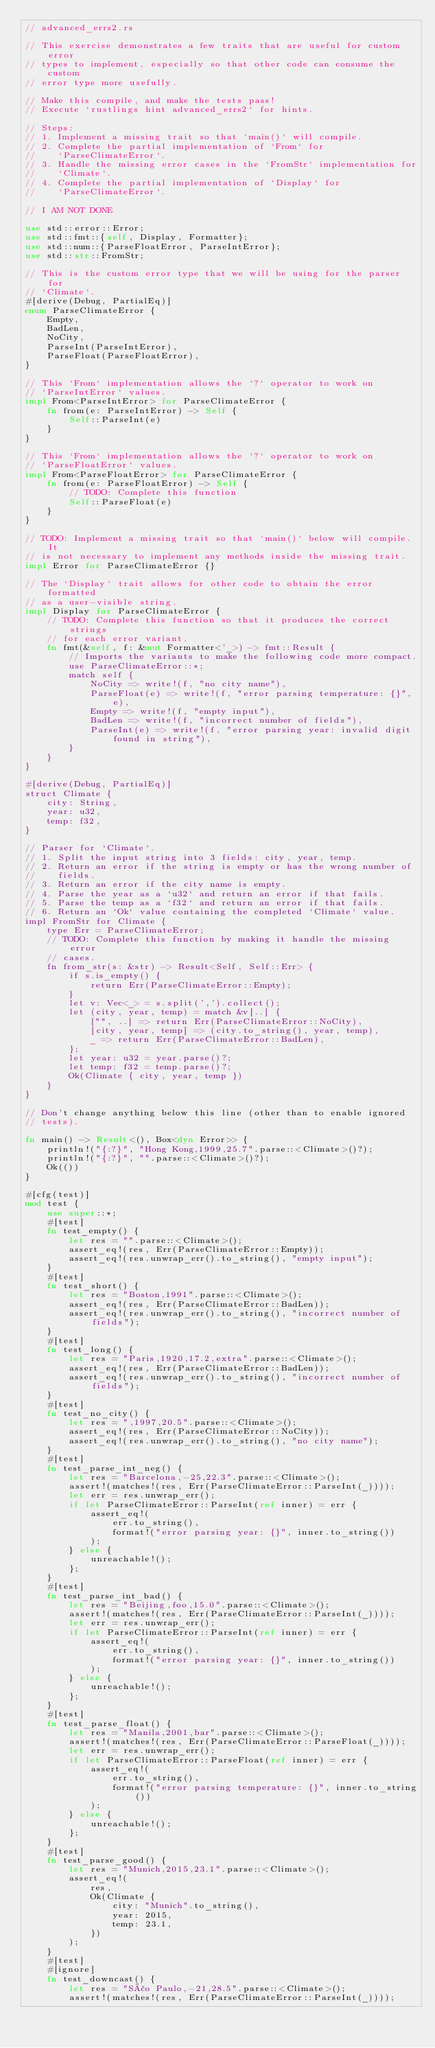<code> <loc_0><loc_0><loc_500><loc_500><_Rust_>// advanced_errs2.rs

// This exercise demonstrates a few traits that are useful for custom error
// types to implement, especially so that other code can consume the custom
// error type more usefully.

// Make this compile, and make the tests pass!
// Execute `rustlings hint advanced_errs2` for hints.

// Steps:
// 1. Implement a missing trait so that `main()` will compile.
// 2. Complete the partial implementation of `From` for
//    `ParseClimateError`.
// 3. Handle the missing error cases in the `FromStr` implementation for
//    `Climate`.
// 4. Complete the partial implementation of `Display` for
//    `ParseClimateError`.

// I AM NOT DONE

use std::error::Error;
use std::fmt::{self, Display, Formatter};
use std::num::{ParseFloatError, ParseIntError};
use std::str::FromStr;

// This is the custom error type that we will be using for the parser for
// `Climate`.
#[derive(Debug, PartialEq)]
enum ParseClimateError {
    Empty,
    BadLen,
    NoCity,
    ParseInt(ParseIntError),
    ParseFloat(ParseFloatError),
}

// This `From` implementation allows the `?` operator to work on
// `ParseIntError` values.
impl From<ParseIntError> for ParseClimateError {
    fn from(e: ParseIntError) -> Self {
        Self::ParseInt(e)
    }
}

// This `From` implementation allows the `?` operator to work on
// `ParseFloatError` values.
impl From<ParseFloatError> for ParseClimateError {
    fn from(e: ParseFloatError) -> Self {
        // TODO: Complete this function
        Self::ParseFloat(e)
    }
}

// TODO: Implement a missing trait so that `main()` below will compile. It
// is not necessary to implement any methods inside the missing trait.
impl Error for ParseClimateError {}

// The `Display` trait allows for other code to obtain the error formatted
// as a user-visible string.
impl Display for ParseClimateError {
    // TODO: Complete this function so that it produces the correct strings
    // for each error variant.
    fn fmt(&self, f: &mut Formatter<'_>) -> fmt::Result {
        // Imports the variants to make the following code more compact.
        use ParseClimateError::*;
        match self {
            NoCity => write!(f, "no city name"),
            ParseFloat(e) => write!(f, "error parsing temperature: {}", e),
            Empty => write!(f, "empty input"),
            BadLen => write!(f, "incorrect number of fields"),
            ParseInt(e) => write!(f, "error parsing year: invalid digit found in string"),
        }
    }
}

#[derive(Debug, PartialEq)]
struct Climate {
    city: String,
    year: u32,
    temp: f32,
}

// Parser for `Climate`.
// 1. Split the input string into 3 fields: city, year, temp.
// 2. Return an error if the string is empty or has the wrong number of
//    fields.
// 3. Return an error if the city name is empty.
// 4. Parse the year as a `u32` and return an error if that fails.
// 5. Parse the temp as a `f32` and return an error if that fails.
// 6. Return an `Ok` value containing the completed `Climate` value.
impl FromStr for Climate {
    type Err = ParseClimateError;
    // TODO: Complete this function by making it handle the missing error
    // cases.
    fn from_str(s: &str) -> Result<Self, Self::Err> {
        if s.is_empty() {
            return Err(ParseClimateError::Empty);
        }
        let v: Vec<_> = s.split(',').collect();
        let (city, year, temp) = match &v[..] {
            ["", ..] => return Err(ParseClimateError::NoCity),
            [city, year, temp] => (city.to_string(), year, temp),
            _ => return Err(ParseClimateError::BadLen),
        };
        let year: u32 = year.parse()?;
        let temp: f32 = temp.parse()?;
        Ok(Climate { city, year, temp })
    }
}

// Don't change anything below this line (other than to enable ignored
// tests).

fn main() -> Result<(), Box<dyn Error>> {
    println!("{:?}", "Hong Kong,1999,25.7".parse::<Climate>()?);
    println!("{:?}", "".parse::<Climate>()?);
    Ok(())
}

#[cfg(test)]
mod test {
    use super::*;
    #[test]
    fn test_empty() {
        let res = "".parse::<Climate>();
        assert_eq!(res, Err(ParseClimateError::Empty));
        assert_eq!(res.unwrap_err().to_string(), "empty input");
    }
    #[test]
    fn test_short() {
        let res = "Boston,1991".parse::<Climate>();
        assert_eq!(res, Err(ParseClimateError::BadLen));
        assert_eq!(res.unwrap_err().to_string(), "incorrect number of fields");
    }
    #[test]
    fn test_long() {
        let res = "Paris,1920,17.2,extra".parse::<Climate>();
        assert_eq!(res, Err(ParseClimateError::BadLen));
        assert_eq!(res.unwrap_err().to_string(), "incorrect number of fields");
    }
    #[test]
    fn test_no_city() {
        let res = ",1997,20.5".parse::<Climate>();
        assert_eq!(res, Err(ParseClimateError::NoCity));
        assert_eq!(res.unwrap_err().to_string(), "no city name");
    }
    #[test]
    fn test_parse_int_neg() {
        let res = "Barcelona,-25,22.3".parse::<Climate>();
        assert!(matches!(res, Err(ParseClimateError::ParseInt(_))));
        let err = res.unwrap_err();
        if let ParseClimateError::ParseInt(ref inner) = err {
            assert_eq!(
                err.to_string(),
                format!("error parsing year: {}", inner.to_string())
            );
        } else {
            unreachable!();
        };
    }
    #[test]
    fn test_parse_int_bad() {
        let res = "Beijing,foo,15.0".parse::<Climate>();
        assert!(matches!(res, Err(ParseClimateError::ParseInt(_))));
        let err = res.unwrap_err();
        if let ParseClimateError::ParseInt(ref inner) = err {
            assert_eq!(
                err.to_string(),
                format!("error parsing year: {}", inner.to_string())
            );
        } else {
            unreachable!();
        };
    }
    #[test]
    fn test_parse_float() {
        let res = "Manila,2001,bar".parse::<Climate>();
        assert!(matches!(res, Err(ParseClimateError::ParseFloat(_))));
        let err = res.unwrap_err();
        if let ParseClimateError::ParseFloat(ref inner) = err {
            assert_eq!(
                err.to_string(),
                format!("error parsing temperature: {}", inner.to_string())
            );
        } else {
            unreachable!();
        };
    }
    #[test]
    fn test_parse_good() {
        let res = "Munich,2015,23.1".parse::<Climate>();
        assert_eq!(
            res,
            Ok(Climate {
                city: "Munich".to_string(),
                year: 2015,
                temp: 23.1,
            })
        );
    }
    #[test]
    #[ignore]
    fn test_downcast() {
        let res = "São Paulo,-21,28.5".parse::<Climate>();
        assert!(matches!(res, Err(ParseClimateError::ParseInt(_))));</code> 